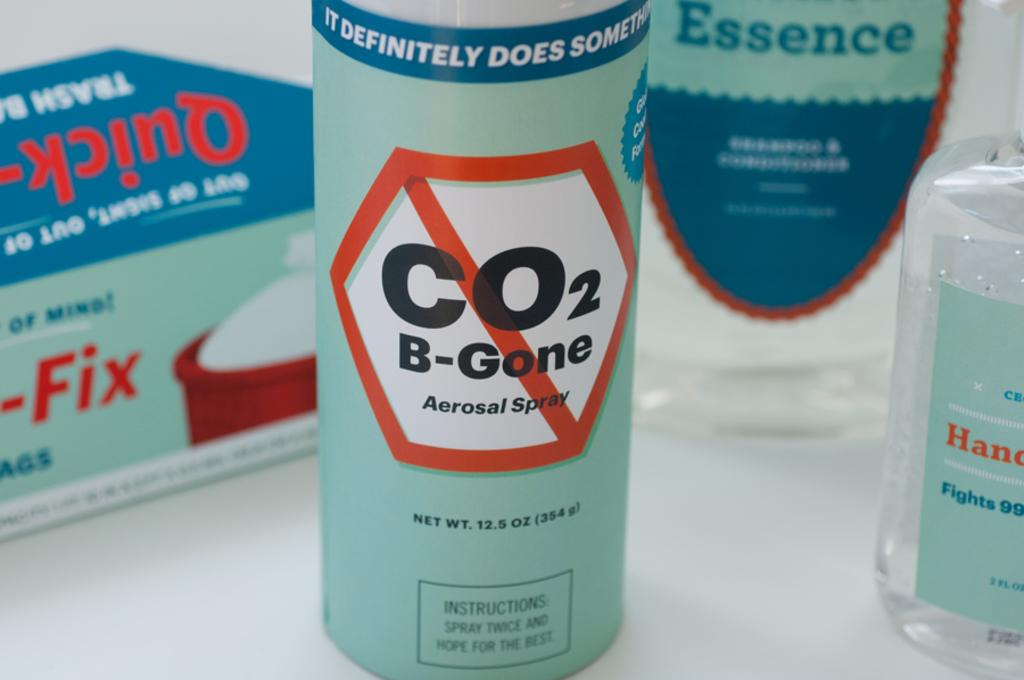Provide a one-sentence caption for the provided image. Bottle  of spray that says CO2 B-Gone. 